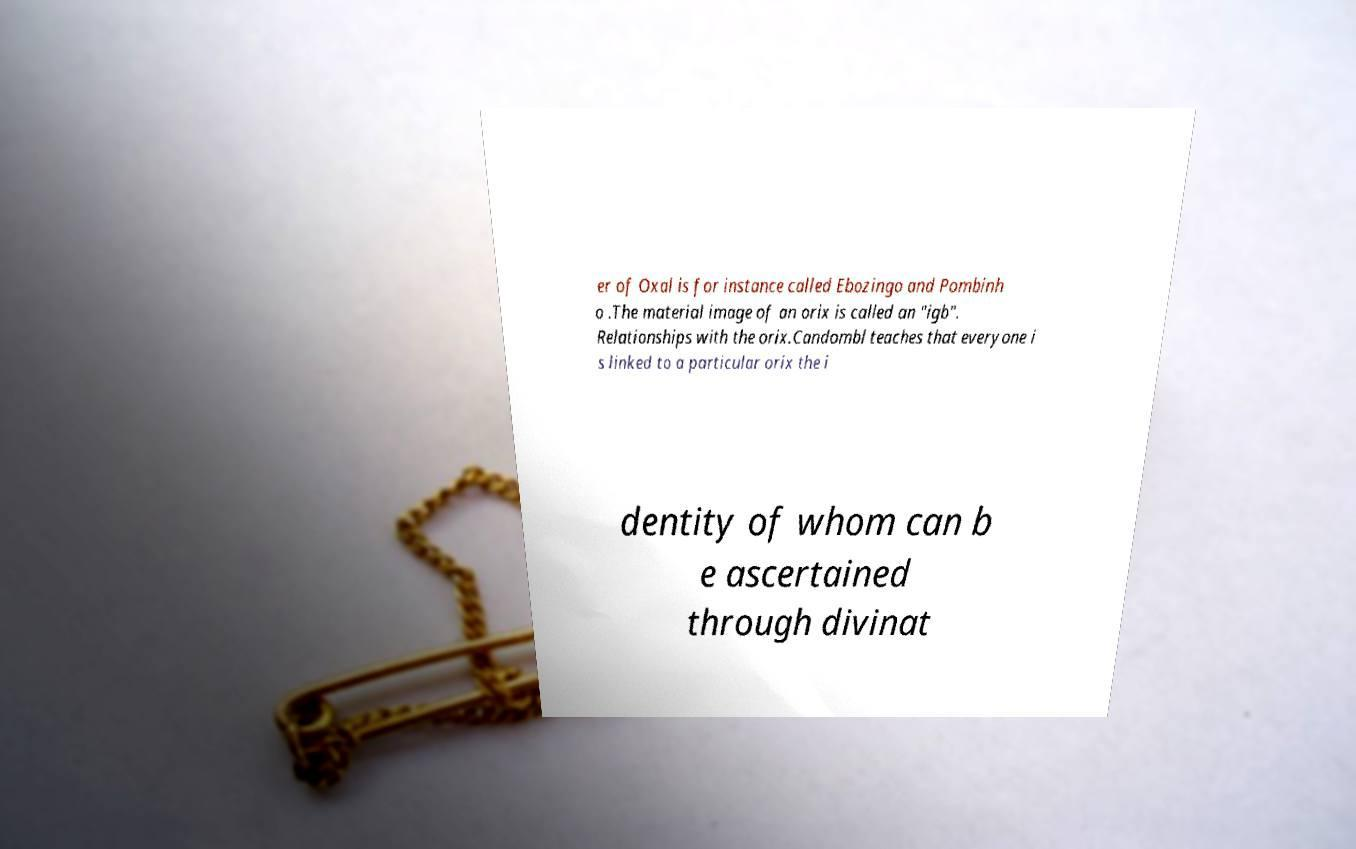Could you extract and type out the text from this image? er of Oxal is for instance called Ebozingo and Pombinh o .The material image of an orix is called an "igb". Relationships with the orix.Candombl teaches that everyone i s linked to a particular orix the i dentity of whom can b e ascertained through divinat 